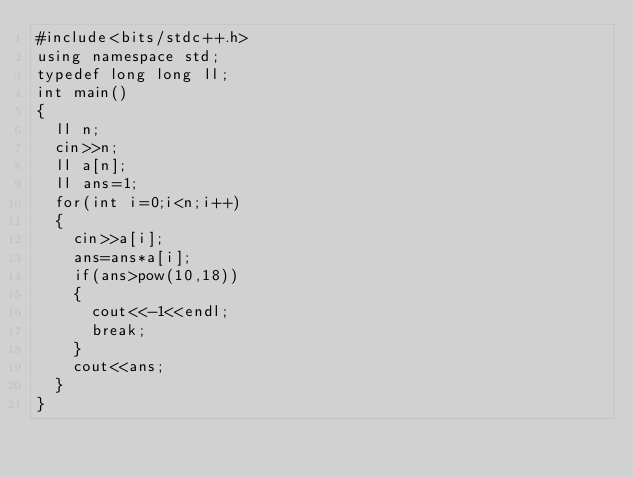Convert code to text. <code><loc_0><loc_0><loc_500><loc_500><_C++_>#include<bits/stdc++.h>
using namespace std;
typedef long long ll;
int main()
{
  ll n;
  cin>>n;
  ll a[n];
  ll ans=1;
  for(int i=0;i<n;i++)
  {
    cin>>a[i];
    ans=ans*a[i];
    if(ans>pow(10,18))
    {
      cout<<-1<<endl;
      break;
    }
    cout<<ans;
  }
}</code> 